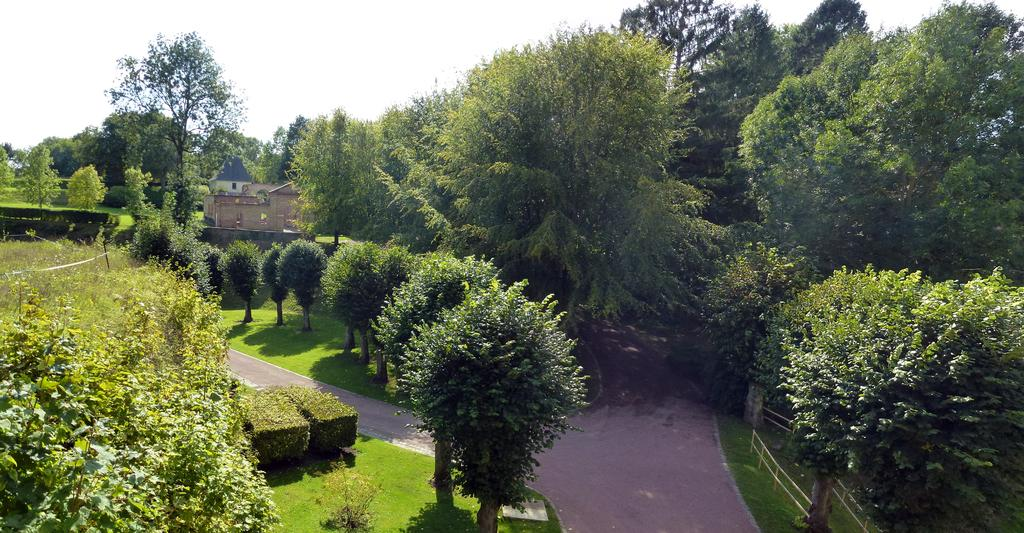What type of vegetation can be seen in the image? There are trees, shrubs, and grass in the image. What type of man-made structures are present in the image? There are roads, a fence, and a stone building in the image. What is visible in the background of the image? The sky is visible in the background of the image. What type of punishment is being administered to the trees in the image? There is no punishment being administered to the trees in the image; they are simply part of the natural landscape. What type of learning can be observed taking place in the image? There is no learning taking place in the image; it is a scene of nature and man-made structures. 